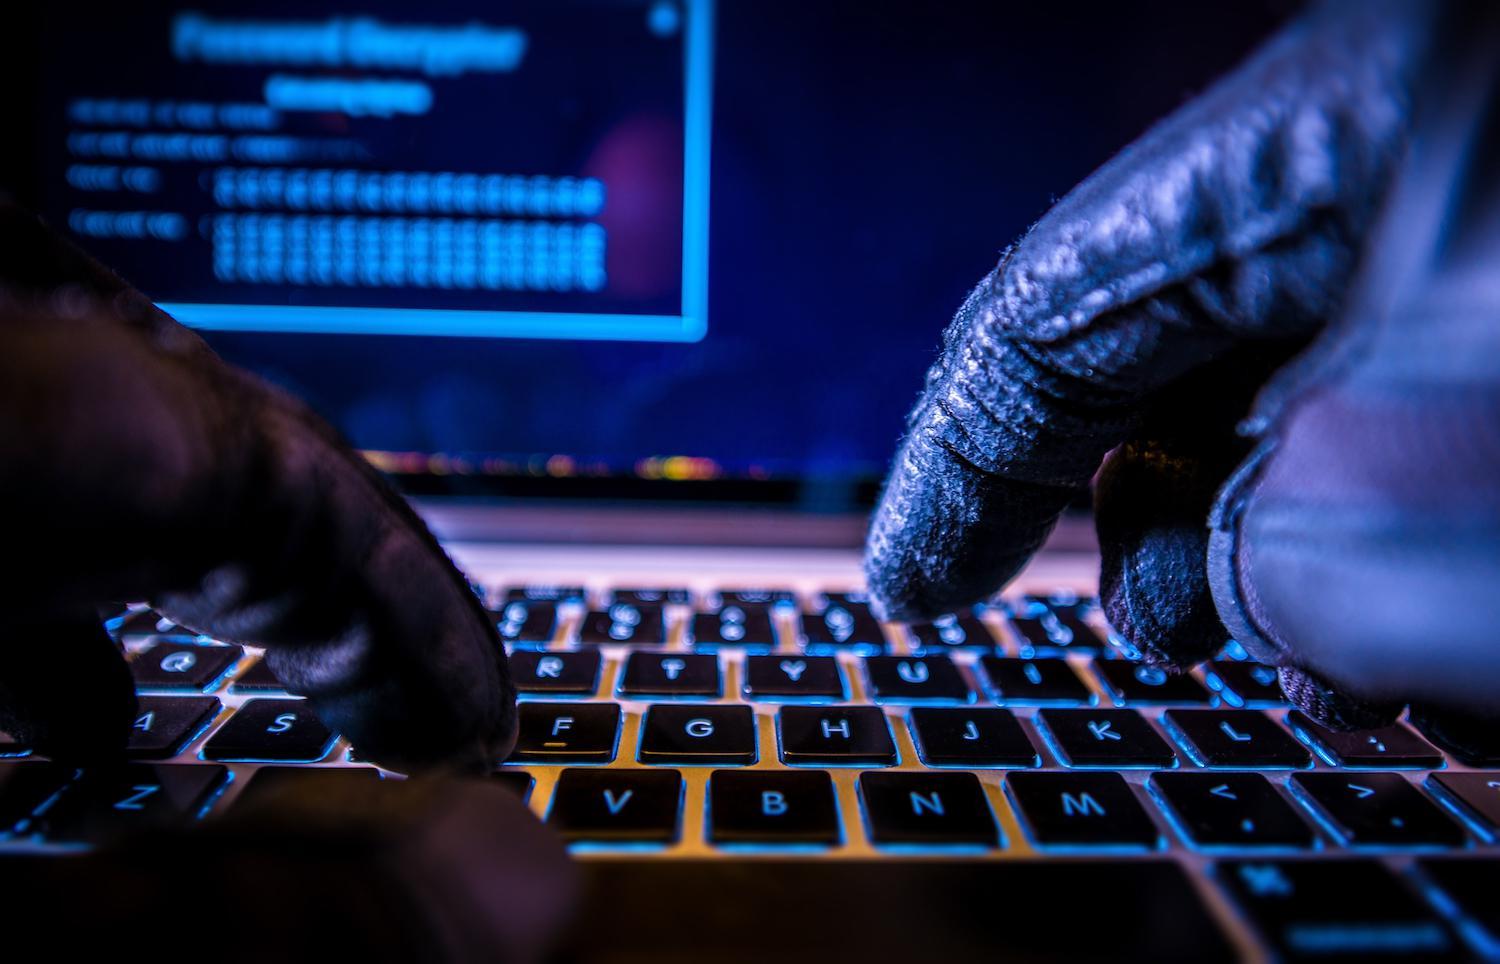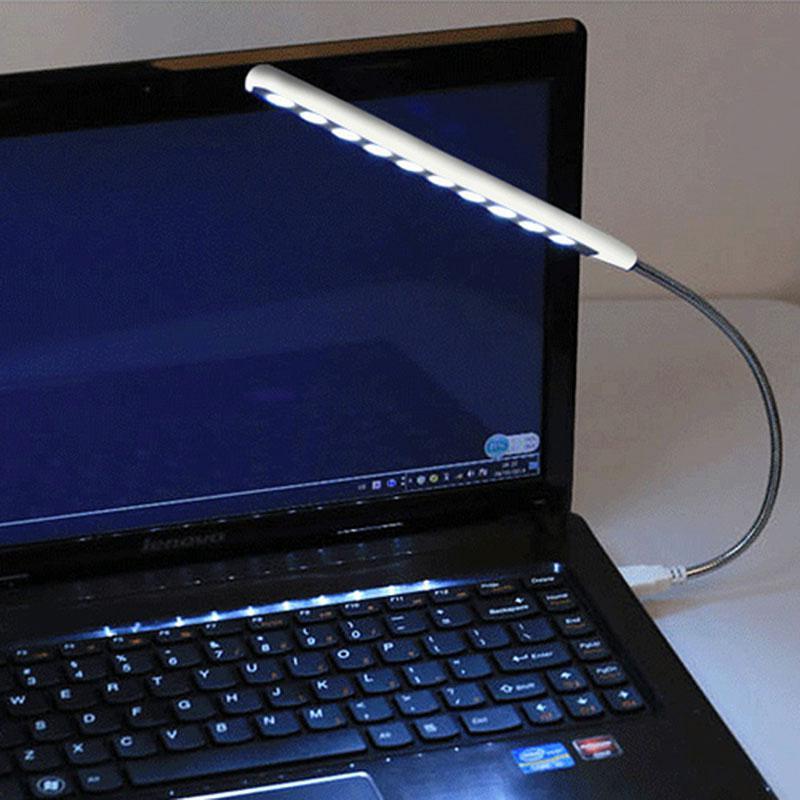The first image is the image on the left, the second image is the image on the right. For the images displayed, is the sentence "A light source is attached to a laptop" factually correct? Answer yes or no. Yes. The first image is the image on the left, the second image is the image on the right. Considering the images on both sides, is "In 1 of the images, 2 hands are typing." valid? Answer yes or no. Yes. 